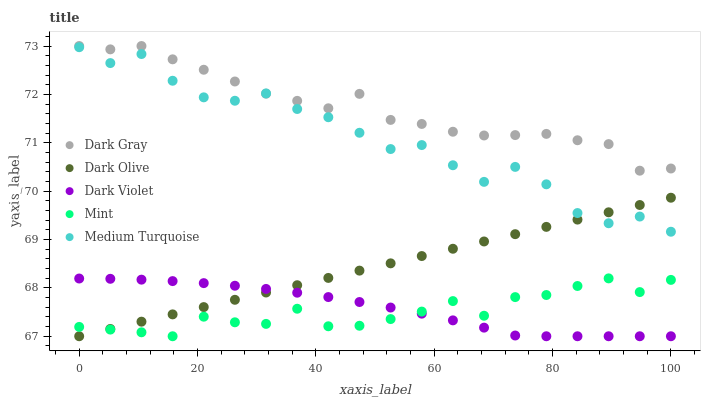Does Mint have the minimum area under the curve?
Answer yes or no. Yes. Does Dark Gray have the maximum area under the curve?
Answer yes or no. Yes. Does Dark Olive have the minimum area under the curve?
Answer yes or no. No. Does Dark Olive have the maximum area under the curve?
Answer yes or no. No. Is Dark Olive the smoothest?
Answer yes or no. Yes. Is Medium Turquoise the roughest?
Answer yes or no. Yes. Is Mint the smoothest?
Answer yes or no. No. Is Mint the roughest?
Answer yes or no. No. Does Dark Olive have the lowest value?
Answer yes or no. Yes. Does Medium Turquoise have the lowest value?
Answer yes or no. No. Does Dark Gray have the highest value?
Answer yes or no. Yes. Does Dark Olive have the highest value?
Answer yes or no. No. Is Mint less than Dark Gray?
Answer yes or no. Yes. Is Dark Gray greater than Dark Olive?
Answer yes or no. Yes. Does Dark Gray intersect Medium Turquoise?
Answer yes or no. Yes. Is Dark Gray less than Medium Turquoise?
Answer yes or no. No. Is Dark Gray greater than Medium Turquoise?
Answer yes or no. No. Does Mint intersect Dark Gray?
Answer yes or no. No. 